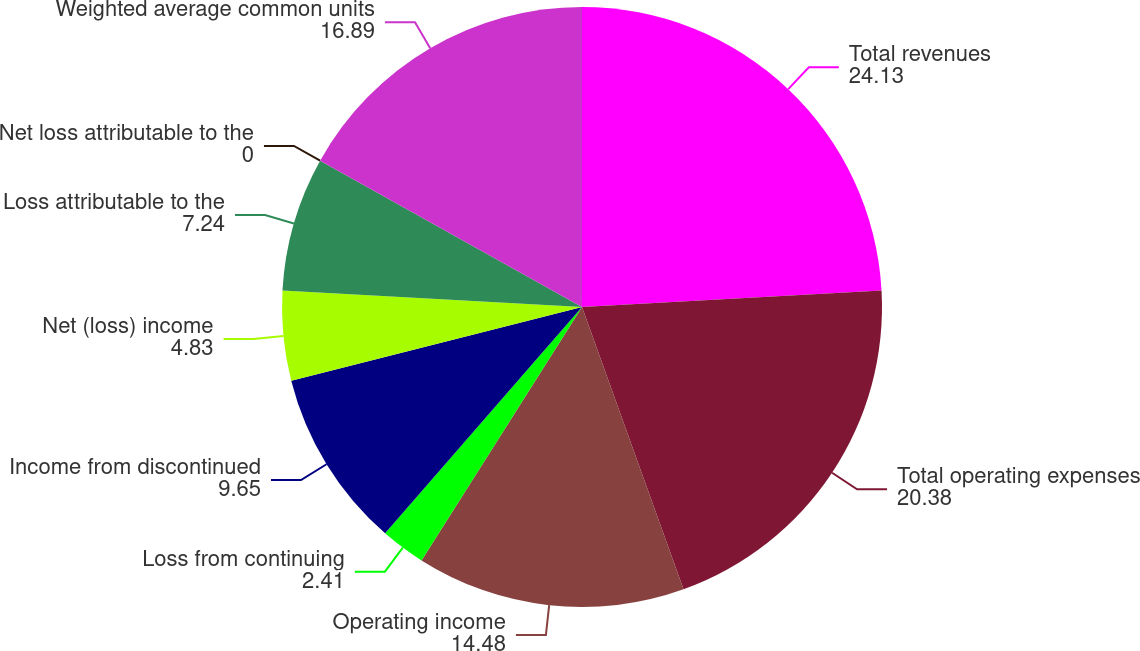Convert chart. <chart><loc_0><loc_0><loc_500><loc_500><pie_chart><fcel>Total revenues<fcel>Total operating expenses<fcel>Operating income<fcel>Loss from continuing<fcel>Income from discontinued<fcel>Net (loss) income<fcel>Loss attributable to the<fcel>Net loss attributable to the<fcel>Weighted average common units<nl><fcel>24.13%<fcel>20.38%<fcel>14.48%<fcel>2.41%<fcel>9.65%<fcel>4.83%<fcel>7.24%<fcel>0.0%<fcel>16.89%<nl></chart> 